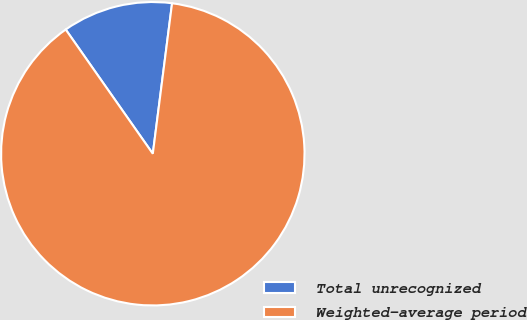Convert chart to OTSL. <chart><loc_0><loc_0><loc_500><loc_500><pie_chart><fcel>Total unrecognized<fcel>Weighted-average period<nl><fcel>11.76%<fcel>88.24%<nl></chart> 